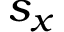<formula> <loc_0><loc_0><loc_500><loc_500>s _ { x }</formula> 